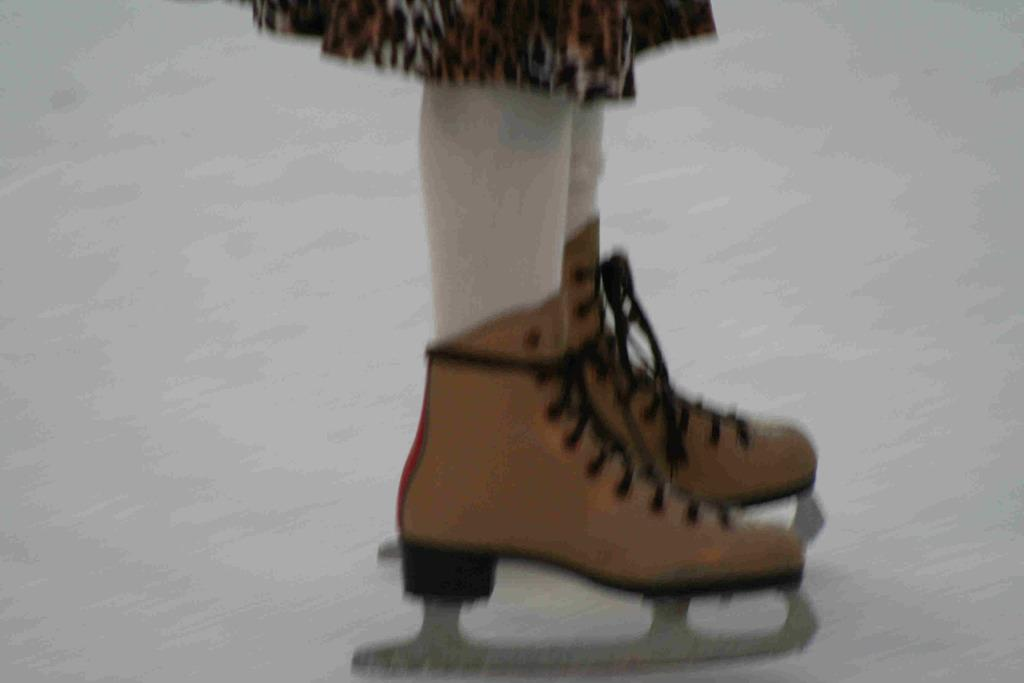What part of a person can be seen in the image? A person's legs are visible in the image. What type of footwear is the person wearing? The person is wearing ice skating shoes. Can you describe the background of the image? The background of the image is blurry. What type of coat is the person wearing in the image? There is no coat visible in the image; only the person's legs and ice skating shoes can be seen. 